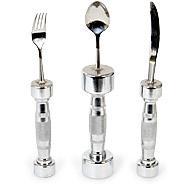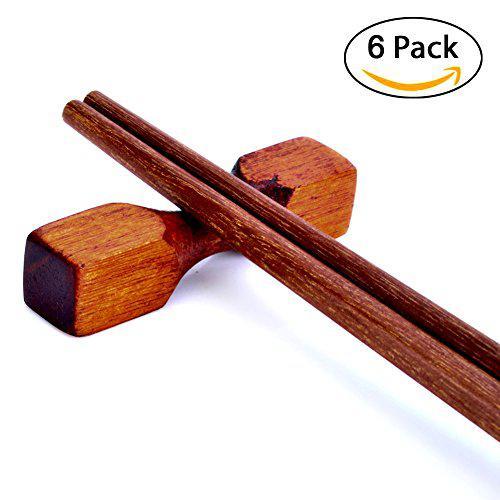The first image is the image on the left, the second image is the image on the right. Assess this claim about the two images: "Left image shows three utensils with barbell-shaped handles.". Correct or not? Answer yes or no. Yes. The first image is the image on the left, the second image is the image on the right. For the images displayed, is the sentence "One image shows a matched set of knife, fork, and spoon utensils standing on end." factually correct? Answer yes or no. Yes. 